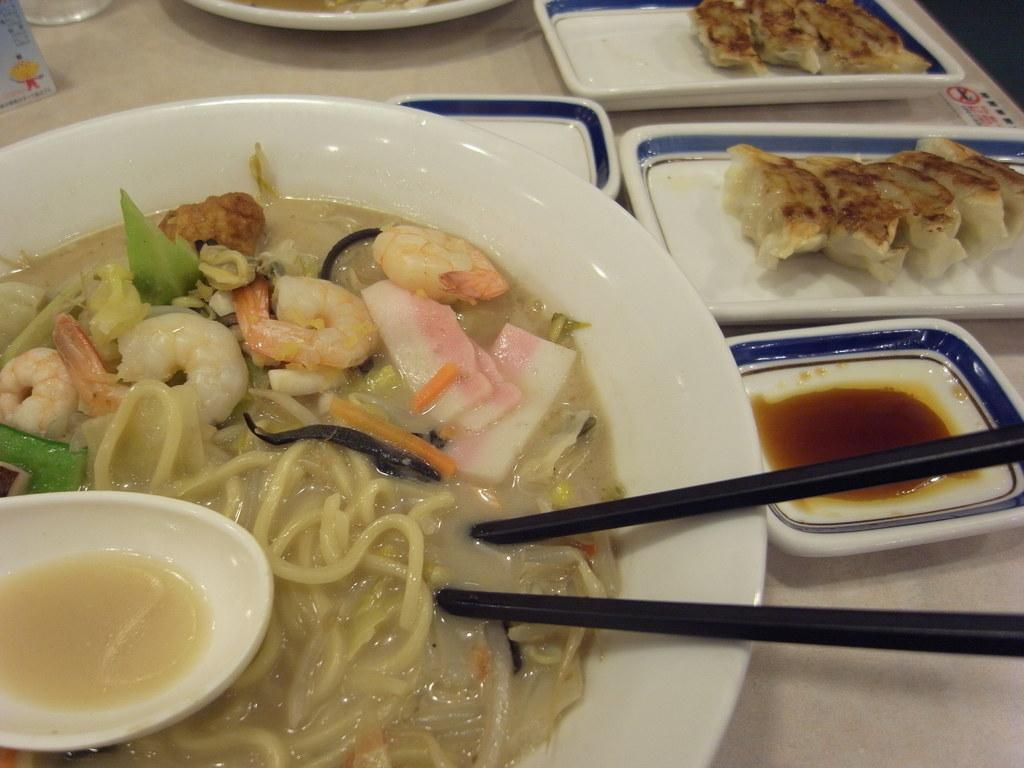What types of food can be seen in the image? There are foods in different plates in the image. How are the foods being eaten or served? Two chopsticks are visible in the image, which suggests that the food might be eaten with chopsticks. How does the twist in the image contribute to the comfort of the food? There is no twist present in the image, and the concept of comfort does not apply to the food or the image. 